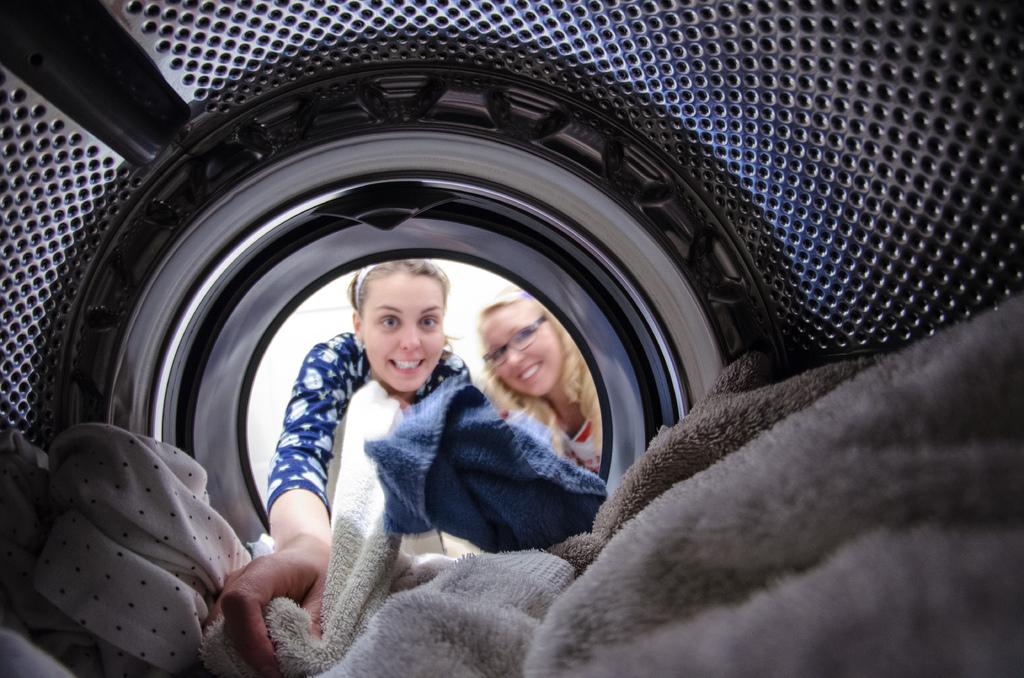What is the woman in the image doing? The woman is pulling a blanket from a washing machine. What is the woman wearing? The woman is wearing a dress. Are there any other people in the image? Yes, there is another woman in the image. How is the second woman feeling? The second woman is smiling. What is the second woman wearing? The second woman is wearing spectacles. Reasoning: Let' Let's think step by step in order to produce the conversation. We start by identifying the main subject in the image, which is the woman pulling a blanket from a washing machine. Then, we describe what she is wearing. Next, we acknowledge the presence of another woman in the image and describe her actions and appearance. Each question is designed to elicit a specific detail about the image that is known from the provided facts. Absurd Question/Answer: How many fingers is the woman using to pull the blanket from the washing machine? The number of fingers the woman is using to pull the blanket from the washing machine cannot be determined from the image. What type of mist is present in the image? There is no mist present in the image. 